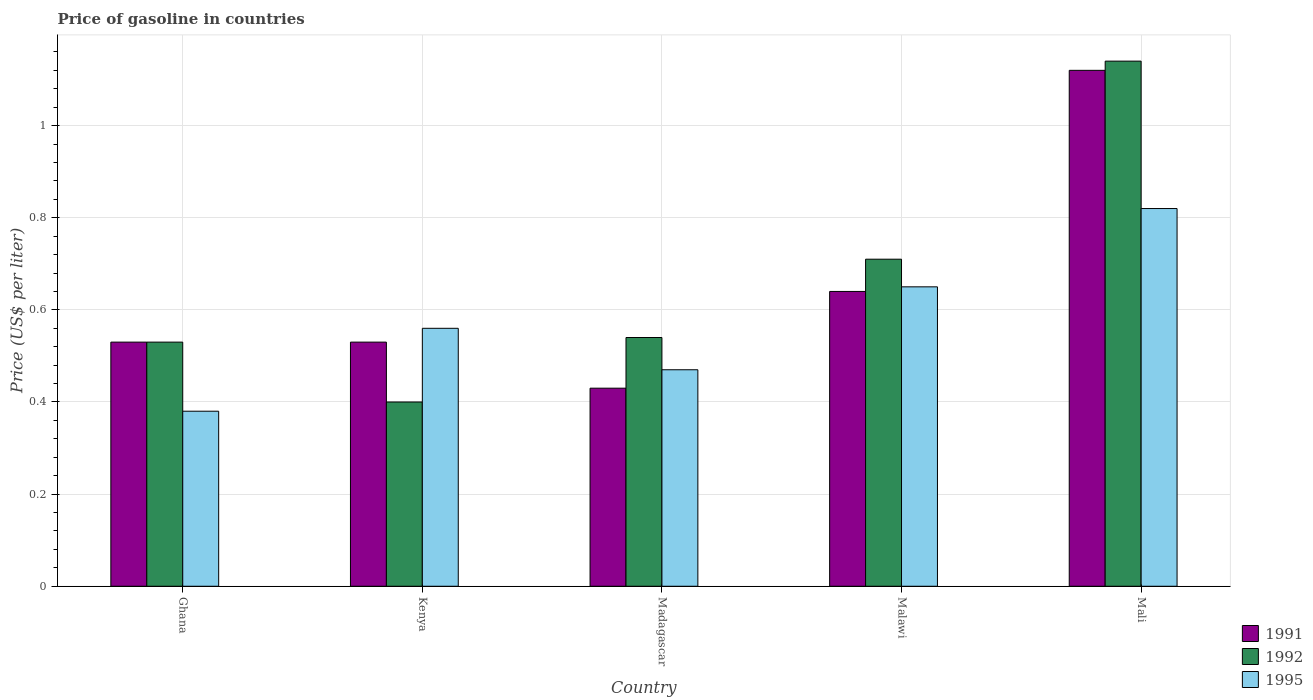How many different coloured bars are there?
Offer a terse response. 3. How many groups of bars are there?
Provide a succinct answer. 5. What is the label of the 2nd group of bars from the left?
Provide a succinct answer. Kenya. In how many cases, is the number of bars for a given country not equal to the number of legend labels?
Make the answer very short. 0. What is the price of gasoline in 1995 in Mali?
Keep it short and to the point. 0.82. Across all countries, what is the maximum price of gasoline in 1991?
Keep it short and to the point. 1.12. Across all countries, what is the minimum price of gasoline in 1991?
Your response must be concise. 0.43. In which country was the price of gasoline in 1995 maximum?
Provide a short and direct response. Mali. In which country was the price of gasoline in 1991 minimum?
Your answer should be very brief. Madagascar. What is the total price of gasoline in 1995 in the graph?
Give a very brief answer. 2.88. What is the difference between the price of gasoline in 1995 in Madagascar and that in Malawi?
Your response must be concise. -0.18. What is the difference between the price of gasoline in 1991 in Kenya and the price of gasoline in 1992 in Malawi?
Your answer should be very brief. -0.18. What is the average price of gasoline in 1992 per country?
Your answer should be very brief. 0.66. What is the difference between the price of gasoline of/in 1991 and price of gasoline of/in 1992 in Kenya?
Offer a terse response. 0.13. In how many countries, is the price of gasoline in 1995 greater than 1 US$?
Provide a succinct answer. 0. What is the ratio of the price of gasoline in 1991 in Ghana to that in Mali?
Provide a succinct answer. 0.47. Is the difference between the price of gasoline in 1991 in Madagascar and Malawi greater than the difference between the price of gasoline in 1992 in Madagascar and Malawi?
Provide a short and direct response. No. What is the difference between the highest and the second highest price of gasoline in 1995?
Offer a very short reply. 0.17. What is the difference between the highest and the lowest price of gasoline in 1991?
Provide a succinct answer. 0.69. Is the sum of the price of gasoline in 1995 in Ghana and Madagascar greater than the maximum price of gasoline in 1992 across all countries?
Provide a succinct answer. No. Is it the case that in every country, the sum of the price of gasoline in 1992 and price of gasoline in 1991 is greater than the price of gasoline in 1995?
Provide a short and direct response. Yes. How many bars are there?
Offer a terse response. 15. How many countries are there in the graph?
Provide a short and direct response. 5. Does the graph contain grids?
Keep it short and to the point. Yes. Where does the legend appear in the graph?
Provide a short and direct response. Bottom right. How many legend labels are there?
Provide a short and direct response. 3. What is the title of the graph?
Your answer should be compact. Price of gasoline in countries. What is the label or title of the X-axis?
Make the answer very short. Country. What is the label or title of the Y-axis?
Offer a terse response. Price (US$ per liter). What is the Price (US$ per liter) of 1991 in Ghana?
Provide a succinct answer. 0.53. What is the Price (US$ per liter) of 1992 in Ghana?
Your response must be concise. 0.53. What is the Price (US$ per liter) of 1995 in Ghana?
Your answer should be compact. 0.38. What is the Price (US$ per liter) in 1991 in Kenya?
Ensure brevity in your answer.  0.53. What is the Price (US$ per liter) of 1995 in Kenya?
Keep it short and to the point. 0.56. What is the Price (US$ per liter) of 1991 in Madagascar?
Give a very brief answer. 0.43. What is the Price (US$ per liter) of 1992 in Madagascar?
Offer a very short reply. 0.54. What is the Price (US$ per liter) of 1995 in Madagascar?
Ensure brevity in your answer.  0.47. What is the Price (US$ per liter) of 1991 in Malawi?
Ensure brevity in your answer.  0.64. What is the Price (US$ per liter) of 1992 in Malawi?
Provide a succinct answer. 0.71. What is the Price (US$ per liter) of 1995 in Malawi?
Ensure brevity in your answer.  0.65. What is the Price (US$ per liter) in 1991 in Mali?
Your response must be concise. 1.12. What is the Price (US$ per liter) of 1992 in Mali?
Your response must be concise. 1.14. What is the Price (US$ per liter) in 1995 in Mali?
Your answer should be very brief. 0.82. Across all countries, what is the maximum Price (US$ per liter) in 1991?
Make the answer very short. 1.12. Across all countries, what is the maximum Price (US$ per liter) of 1992?
Keep it short and to the point. 1.14. Across all countries, what is the maximum Price (US$ per liter) of 1995?
Offer a terse response. 0.82. Across all countries, what is the minimum Price (US$ per liter) in 1991?
Keep it short and to the point. 0.43. Across all countries, what is the minimum Price (US$ per liter) of 1992?
Your response must be concise. 0.4. Across all countries, what is the minimum Price (US$ per liter) in 1995?
Offer a very short reply. 0.38. What is the total Price (US$ per liter) in 1992 in the graph?
Provide a succinct answer. 3.32. What is the total Price (US$ per liter) of 1995 in the graph?
Ensure brevity in your answer.  2.88. What is the difference between the Price (US$ per liter) of 1991 in Ghana and that in Kenya?
Provide a short and direct response. 0. What is the difference between the Price (US$ per liter) in 1992 in Ghana and that in Kenya?
Give a very brief answer. 0.13. What is the difference between the Price (US$ per liter) in 1995 in Ghana and that in Kenya?
Provide a short and direct response. -0.18. What is the difference between the Price (US$ per liter) in 1991 in Ghana and that in Madagascar?
Provide a succinct answer. 0.1. What is the difference between the Price (US$ per liter) in 1992 in Ghana and that in Madagascar?
Your answer should be compact. -0.01. What is the difference between the Price (US$ per liter) of 1995 in Ghana and that in Madagascar?
Your answer should be compact. -0.09. What is the difference between the Price (US$ per liter) in 1991 in Ghana and that in Malawi?
Your answer should be compact. -0.11. What is the difference between the Price (US$ per liter) of 1992 in Ghana and that in Malawi?
Offer a terse response. -0.18. What is the difference between the Price (US$ per liter) of 1995 in Ghana and that in Malawi?
Keep it short and to the point. -0.27. What is the difference between the Price (US$ per liter) of 1991 in Ghana and that in Mali?
Make the answer very short. -0.59. What is the difference between the Price (US$ per liter) of 1992 in Ghana and that in Mali?
Your answer should be very brief. -0.61. What is the difference between the Price (US$ per liter) in 1995 in Ghana and that in Mali?
Keep it short and to the point. -0.44. What is the difference between the Price (US$ per liter) of 1992 in Kenya and that in Madagascar?
Keep it short and to the point. -0.14. What is the difference between the Price (US$ per liter) in 1995 in Kenya and that in Madagascar?
Your response must be concise. 0.09. What is the difference between the Price (US$ per liter) in 1991 in Kenya and that in Malawi?
Provide a short and direct response. -0.11. What is the difference between the Price (US$ per liter) in 1992 in Kenya and that in Malawi?
Ensure brevity in your answer.  -0.31. What is the difference between the Price (US$ per liter) in 1995 in Kenya and that in Malawi?
Keep it short and to the point. -0.09. What is the difference between the Price (US$ per liter) of 1991 in Kenya and that in Mali?
Provide a succinct answer. -0.59. What is the difference between the Price (US$ per liter) of 1992 in Kenya and that in Mali?
Your answer should be very brief. -0.74. What is the difference between the Price (US$ per liter) in 1995 in Kenya and that in Mali?
Ensure brevity in your answer.  -0.26. What is the difference between the Price (US$ per liter) in 1991 in Madagascar and that in Malawi?
Give a very brief answer. -0.21. What is the difference between the Price (US$ per liter) of 1992 in Madagascar and that in Malawi?
Provide a succinct answer. -0.17. What is the difference between the Price (US$ per liter) in 1995 in Madagascar and that in Malawi?
Your response must be concise. -0.18. What is the difference between the Price (US$ per liter) in 1991 in Madagascar and that in Mali?
Offer a terse response. -0.69. What is the difference between the Price (US$ per liter) of 1995 in Madagascar and that in Mali?
Your answer should be very brief. -0.35. What is the difference between the Price (US$ per liter) in 1991 in Malawi and that in Mali?
Your answer should be compact. -0.48. What is the difference between the Price (US$ per liter) of 1992 in Malawi and that in Mali?
Offer a very short reply. -0.43. What is the difference between the Price (US$ per liter) of 1995 in Malawi and that in Mali?
Your answer should be very brief. -0.17. What is the difference between the Price (US$ per liter) of 1991 in Ghana and the Price (US$ per liter) of 1992 in Kenya?
Give a very brief answer. 0.13. What is the difference between the Price (US$ per liter) of 1991 in Ghana and the Price (US$ per liter) of 1995 in Kenya?
Your response must be concise. -0.03. What is the difference between the Price (US$ per liter) of 1992 in Ghana and the Price (US$ per liter) of 1995 in Kenya?
Make the answer very short. -0.03. What is the difference between the Price (US$ per liter) of 1991 in Ghana and the Price (US$ per liter) of 1992 in Madagascar?
Provide a succinct answer. -0.01. What is the difference between the Price (US$ per liter) of 1991 in Ghana and the Price (US$ per liter) of 1992 in Malawi?
Make the answer very short. -0.18. What is the difference between the Price (US$ per liter) of 1991 in Ghana and the Price (US$ per liter) of 1995 in Malawi?
Offer a terse response. -0.12. What is the difference between the Price (US$ per liter) of 1992 in Ghana and the Price (US$ per liter) of 1995 in Malawi?
Provide a succinct answer. -0.12. What is the difference between the Price (US$ per liter) of 1991 in Ghana and the Price (US$ per liter) of 1992 in Mali?
Keep it short and to the point. -0.61. What is the difference between the Price (US$ per liter) of 1991 in Ghana and the Price (US$ per liter) of 1995 in Mali?
Your answer should be compact. -0.29. What is the difference between the Price (US$ per liter) of 1992 in Ghana and the Price (US$ per liter) of 1995 in Mali?
Provide a short and direct response. -0.29. What is the difference between the Price (US$ per liter) of 1991 in Kenya and the Price (US$ per liter) of 1992 in Madagascar?
Ensure brevity in your answer.  -0.01. What is the difference between the Price (US$ per liter) in 1991 in Kenya and the Price (US$ per liter) in 1995 in Madagascar?
Ensure brevity in your answer.  0.06. What is the difference between the Price (US$ per liter) in 1992 in Kenya and the Price (US$ per liter) in 1995 in Madagascar?
Your answer should be very brief. -0.07. What is the difference between the Price (US$ per liter) of 1991 in Kenya and the Price (US$ per liter) of 1992 in Malawi?
Give a very brief answer. -0.18. What is the difference between the Price (US$ per liter) in 1991 in Kenya and the Price (US$ per liter) in 1995 in Malawi?
Give a very brief answer. -0.12. What is the difference between the Price (US$ per liter) of 1991 in Kenya and the Price (US$ per liter) of 1992 in Mali?
Your answer should be very brief. -0.61. What is the difference between the Price (US$ per liter) in 1991 in Kenya and the Price (US$ per liter) in 1995 in Mali?
Your answer should be very brief. -0.29. What is the difference between the Price (US$ per liter) of 1992 in Kenya and the Price (US$ per liter) of 1995 in Mali?
Offer a very short reply. -0.42. What is the difference between the Price (US$ per liter) of 1991 in Madagascar and the Price (US$ per liter) of 1992 in Malawi?
Your response must be concise. -0.28. What is the difference between the Price (US$ per liter) of 1991 in Madagascar and the Price (US$ per liter) of 1995 in Malawi?
Make the answer very short. -0.22. What is the difference between the Price (US$ per liter) in 1992 in Madagascar and the Price (US$ per liter) in 1995 in Malawi?
Ensure brevity in your answer.  -0.11. What is the difference between the Price (US$ per liter) of 1991 in Madagascar and the Price (US$ per liter) of 1992 in Mali?
Make the answer very short. -0.71. What is the difference between the Price (US$ per liter) of 1991 in Madagascar and the Price (US$ per liter) of 1995 in Mali?
Give a very brief answer. -0.39. What is the difference between the Price (US$ per liter) in 1992 in Madagascar and the Price (US$ per liter) in 1995 in Mali?
Give a very brief answer. -0.28. What is the difference between the Price (US$ per liter) in 1991 in Malawi and the Price (US$ per liter) in 1992 in Mali?
Your response must be concise. -0.5. What is the difference between the Price (US$ per liter) in 1991 in Malawi and the Price (US$ per liter) in 1995 in Mali?
Ensure brevity in your answer.  -0.18. What is the difference between the Price (US$ per liter) in 1992 in Malawi and the Price (US$ per liter) in 1995 in Mali?
Provide a succinct answer. -0.11. What is the average Price (US$ per liter) in 1991 per country?
Provide a short and direct response. 0.65. What is the average Price (US$ per liter) of 1992 per country?
Offer a terse response. 0.66. What is the average Price (US$ per liter) of 1995 per country?
Keep it short and to the point. 0.58. What is the difference between the Price (US$ per liter) in 1991 and Price (US$ per liter) in 1992 in Ghana?
Keep it short and to the point. 0. What is the difference between the Price (US$ per liter) of 1991 and Price (US$ per liter) of 1995 in Ghana?
Your answer should be very brief. 0.15. What is the difference between the Price (US$ per liter) of 1991 and Price (US$ per liter) of 1992 in Kenya?
Your response must be concise. 0.13. What is the difference between the Price (US$ per liter) in 1991 and Price (US$ per liter) in 1995 in Kenya?
Keep it short and to the point. -0.03. What is the difference between the Price (US$ per liter) of 1992 and Price (US$ per liter) of 1995 in Kenya?
Provide a short and direct response. -0.16. What is the difference between the Price (US$ per liter) in 1991 and Price (US$ per liter) in 1992 in Madagascar?
Offer a terse response. -0.11. What is the difference between the Price (US$ per liter) in 1991 and Price (US$ per liter) in 1995 in Madagascar?
Make the answer very short. -0.04. What is the difference between the Price (US$ per liter) of 1992 and Price (US$ per liter) of 1995 in Madagascar?
Make the answer very short. 0.07. What is the difference between the Price (US$ per liter) of 1991 and Price (US$ per liter) of 1992 in Malawi?
Your answer should be compact. -0.07. What is the difference between the Price (US$ per liter) in 1991 and Price (US$ per liter) in 1995 in Malawi?
Provide a succinct answer. -0.01. What is the difference between the Price (US$ per liter) of 1991 and Price (US$ per liter) of 1992 in Mali?
Offer a terse response. -0.02. What is the difference between the Price (US$ per liter) of 1991 and Price (US$ per liter) of 1995 in Mali?
Keep it short and to the point. 0.3. What is the difference between the Price (US$ per liter) in 1992 and Price (US$ per liter) in 1995 in Mali?
Provide a succinct answer. 0.32. What is the ratio of the Price (US$ per liter) in 1992 in Ghana to that in Kenya?
Give a very brief answer. 1.32. What is the ratio of the Price (US$ per liter) of 1995 in Ghana to that in Kenya?
Your response must be concise. 0.68. What is the ratio of the Price (US$ per liter) of 1991 in Ghana to that in Madagascar?
Offer a very short reply. 1.23. What is the ratio of the Price (US$ per liter) of 1992 in Ghana to that in Madagascar?
Make the answer very short. 0.98. What is the ratio of the Price (US$ per liter) of 1995 in Ghana to that in Madagascar?
Ensure brevity in your answer.  0.81. What is the ratio of the Price (US$ per liter) in 1991 in Ghana to that in Malawi?
Give a very brief answer. 0.83. What is the ratio of the Price (US$ per liter) of 1992 in Ghana to that in Malawi?
Make the answer very short. 0.75. What is the ratio of the Price (US$ per liter) of 1995 in Ghana to that in Malawi?
Offer a terse response. 0.58. What is the ratio of the Price (US$ per liter) in 1991 in Ghana to that in Mali?
Provide a succinct answer. 0.47. What is the ratio of the Price (US$ per liter) in 1992 in Ghana to that in Mali?
Your answer should be very brief. 0.46. What is the ratio of the Price (US$ per liter) of 1995 in Ghana to that in Mali?
Provide a succinct answer. 0.46. What is the ratio of the Price (US$ per liter) of 1991 in Kenya to that in Madagascar?
Ensure brevity in your answer.  1.23. What is the ratio of the Price (US$ per liter) of 1992 in Kenya to that in Madagascar?
Your response must be concise. 0.74. What is the ratio of the Price (US$ per liter) of 1995 in Kenya to that in Madagascar?
Offer a very short reply. 1.19. What is the ratio of the Price (US$ per liter) of 1991 in Kenya to that in Malawi?
Offer a terse response. 0.83. What is the ratio of the Price (US$ per liter) of 1992 in Kenya to that in Malawi?
Provide a short and direct response. 0.56. What is the ratio of the Price (US$ per liter) in 1995 in Kenya to that in Malawi?
Keep it short and to the point. 0.86. What is the ratio of the Price (US$ per liter) of 1991 in Kenya to that in Mali?
Ensure brevity in your answer.  0.47. What is the ratio of the Price (US$ per liter) of 1992 in Kenya to that in Mali?
Your answer should be compact. 0.35. What is the ratio of the Price (US$ per liter) in 1995 in Kenya to that in Mali?
Offer a very short reply. 0.68. What is the ratio of the Price (US$ per liter) of 1991 in Madagascar to that in Malawi?
Your answer should be very brief. 0.67. What is the ratio of the Price (US$ per liter) of 1992 in Madagascar to that in Malawi?
Provide a succinct answer. 0.76. What is the ratio of the Price (US$ per liter) in 1995 in Madagascar to that in Malawi?
Offer a very short reply. 0.72. What is the ratio of the Price (US$ per liter) of 1991 in Madagascar to that in Mali?
Ensure brevity in your answer.  0.38. What is the ratio of the Price (US$ per liter) in 1992 in Madagascar to that in Mali?
Your answer should be compact. 0.47. What is the ratio of the Price (US$ per liter) of 1995 in Madagascar to that in Mali?
Your response must be concise. 0.57. What is the ratio of the Price (US$ per liter) in 1992 in Malawi to that in Mali?
Provide a short and direct response. 0.62. What is the ratio of the Price (US$ per liter) in 1995 in Malawi to that in Mali?
Ensure brevity in your answer.  0.79. What is the difference between the highest and the second highest Price (US$ per liter) in 1991?
Your answer should be compact. 0.48. What is the difference between the highest and the second highest Price (US$ per liter) in 1992?
Provide a succinct answer. 0.43. What is the difference between the highest and the second highest Price (US$ per liter) of 1995?
Provide a succinct answer. 0.17. What is the difference between the highest and the lowest Price (US$ per liter) of 1991?
Offer a terse response. 0.69. What is the difference between the highest and the lowest Price (US$ per liter) of 1992?
Offer a terse response. 0.74. What is the difference between the highest and the lowest Price (US$ per liter) of 1995?
Ensure brevity in your answer.  0.44. 